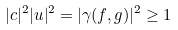<formula> <loc_0><loc_0><loc_500><loc_500>| c | ^ { 2 } | u | ^ { 2 } = | \gamma ( f , g ) | ^ { 2 } \geq 1</formula> 